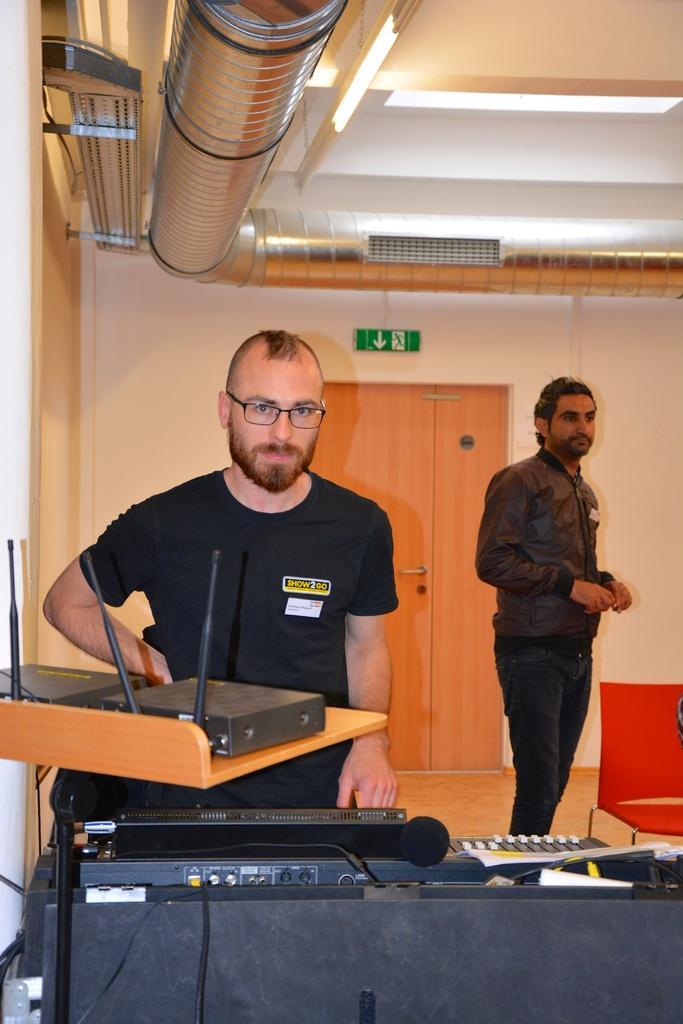In one or two sentences, can you explain what this image depicts? In this image we can see two persons. We can also see some instruments on the black color table and there are two black color boxes on the wooden surface. In the background we can see the wall, door, chair and at the top we can see the ceiling with the lights. We can also see the pipes. 